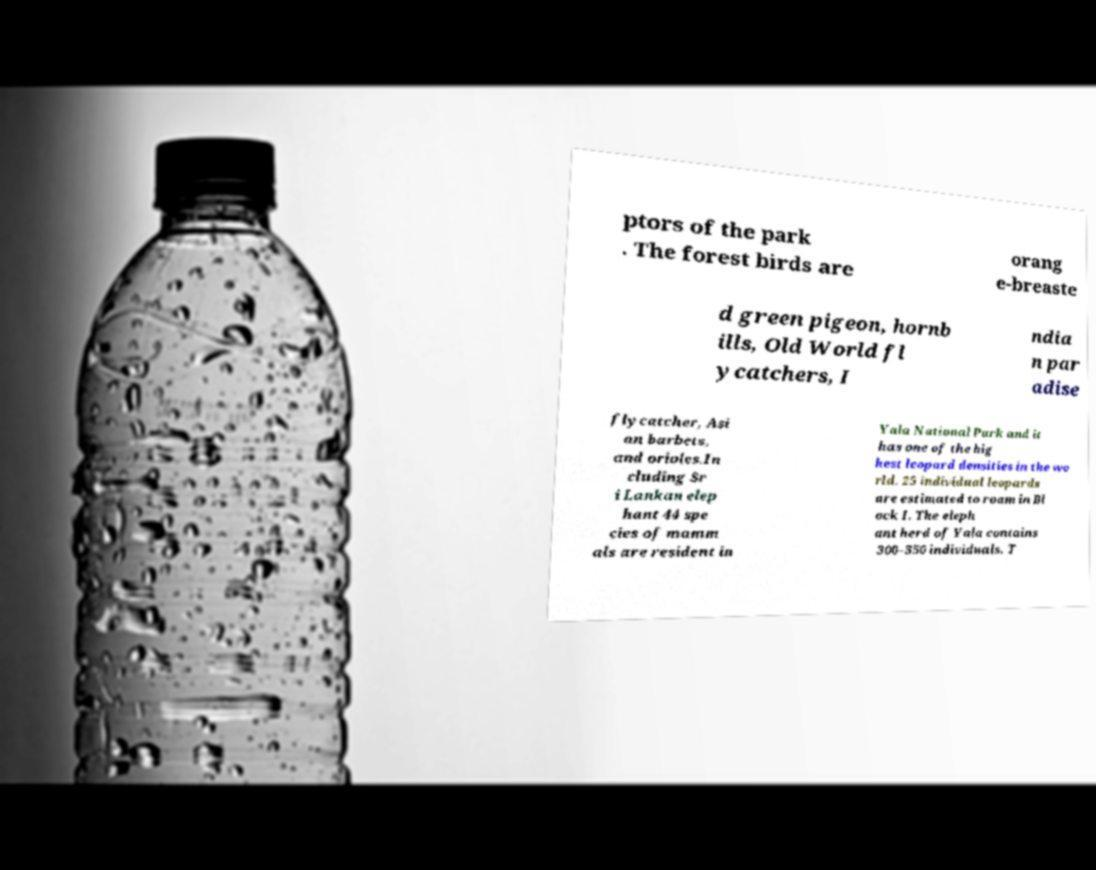Can you accurately transcribe the text from the provided image for me? ptors of the park . The forest birds are orang e-breaste d green pigeon, hornb ills, Old World fl ycatchers, I ndia n par adise flycatcher, Asi an barbets, and orioles.In cluding Sr i Lankan elep hant 44 spe cies of mamm als are resident in Yala National Park and it has one of the hig hest leopard densities in the wo rld. 25 individual leopards are estimated to roam in Bl ock I. The eleph ant herd of Yala contains 300–350 individuals. T 